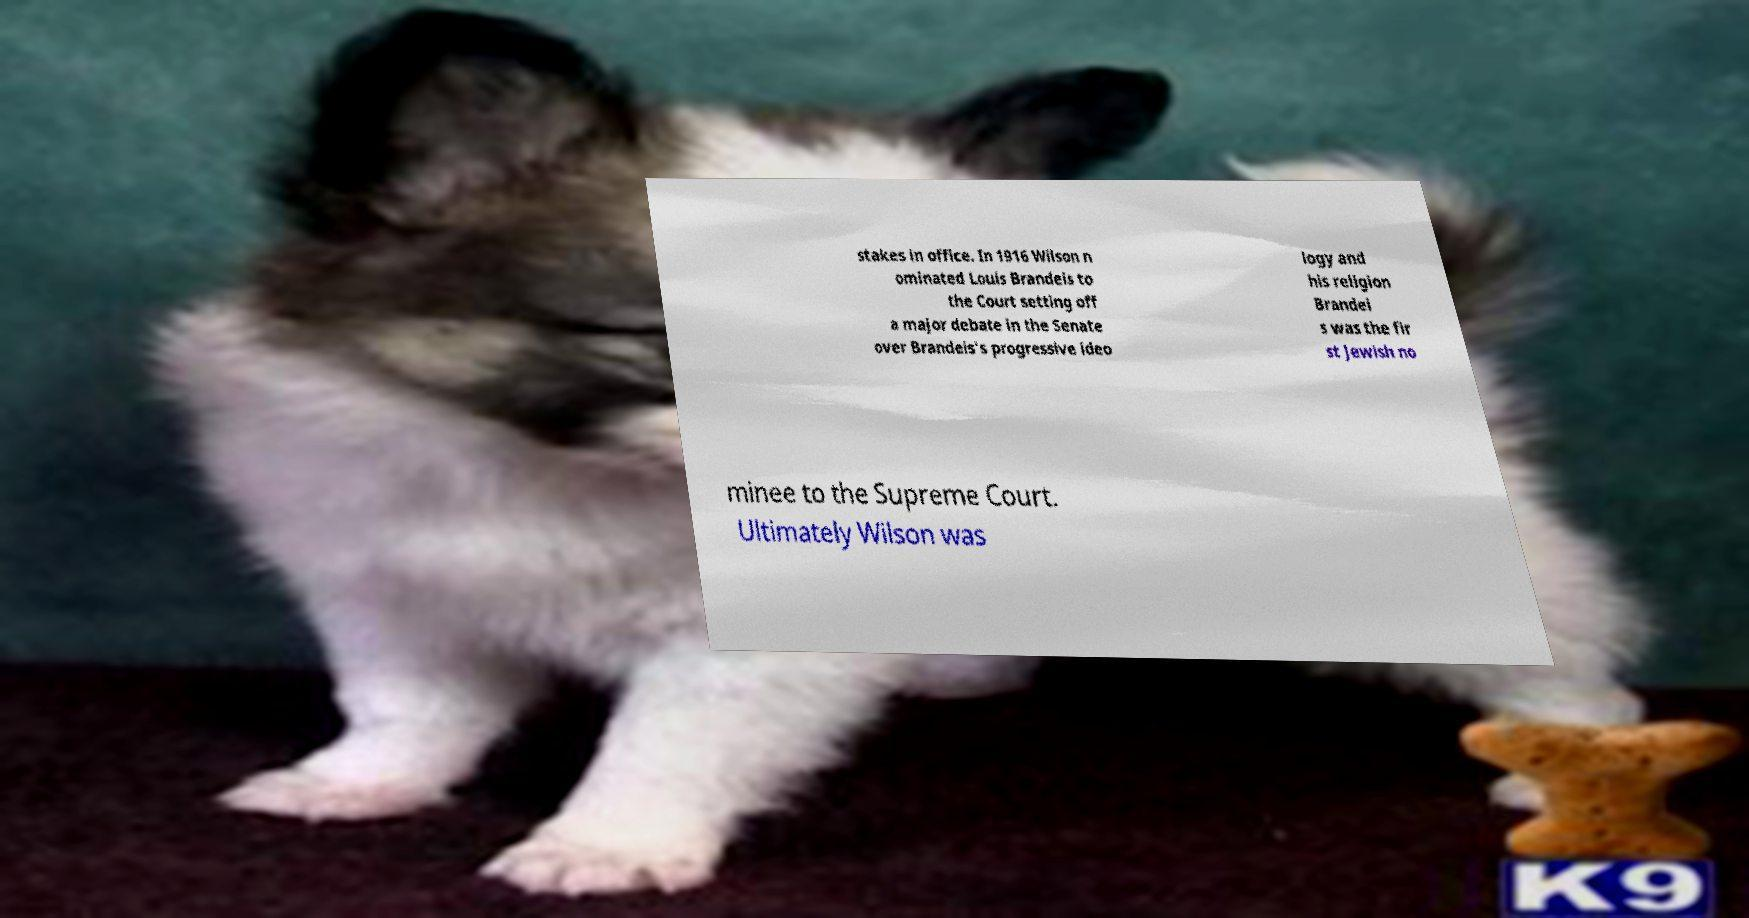Could you extract and type out the text from this image? stakes in office. In 1916 Wilson n ominated Louis Brandeis to the Court setting off a major debate in the Senate over Brandeis's progressive ideo logy and his religion Brandei s was the fir st Jewish no minee to the Supreme Court. Ultimately Wilson was 